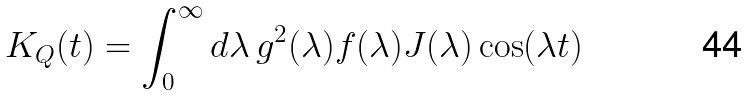<formula> <loc_0><loc_0><loc_500><loc_500>K _ { Q } ( t ) = \int _ { 0 } ^ { \infty } d \lambda \, g ^ { 2 } ( \lambda ) f ( \lambda ) J ( \lambda ) \cos ( \lambda t )</formula> 